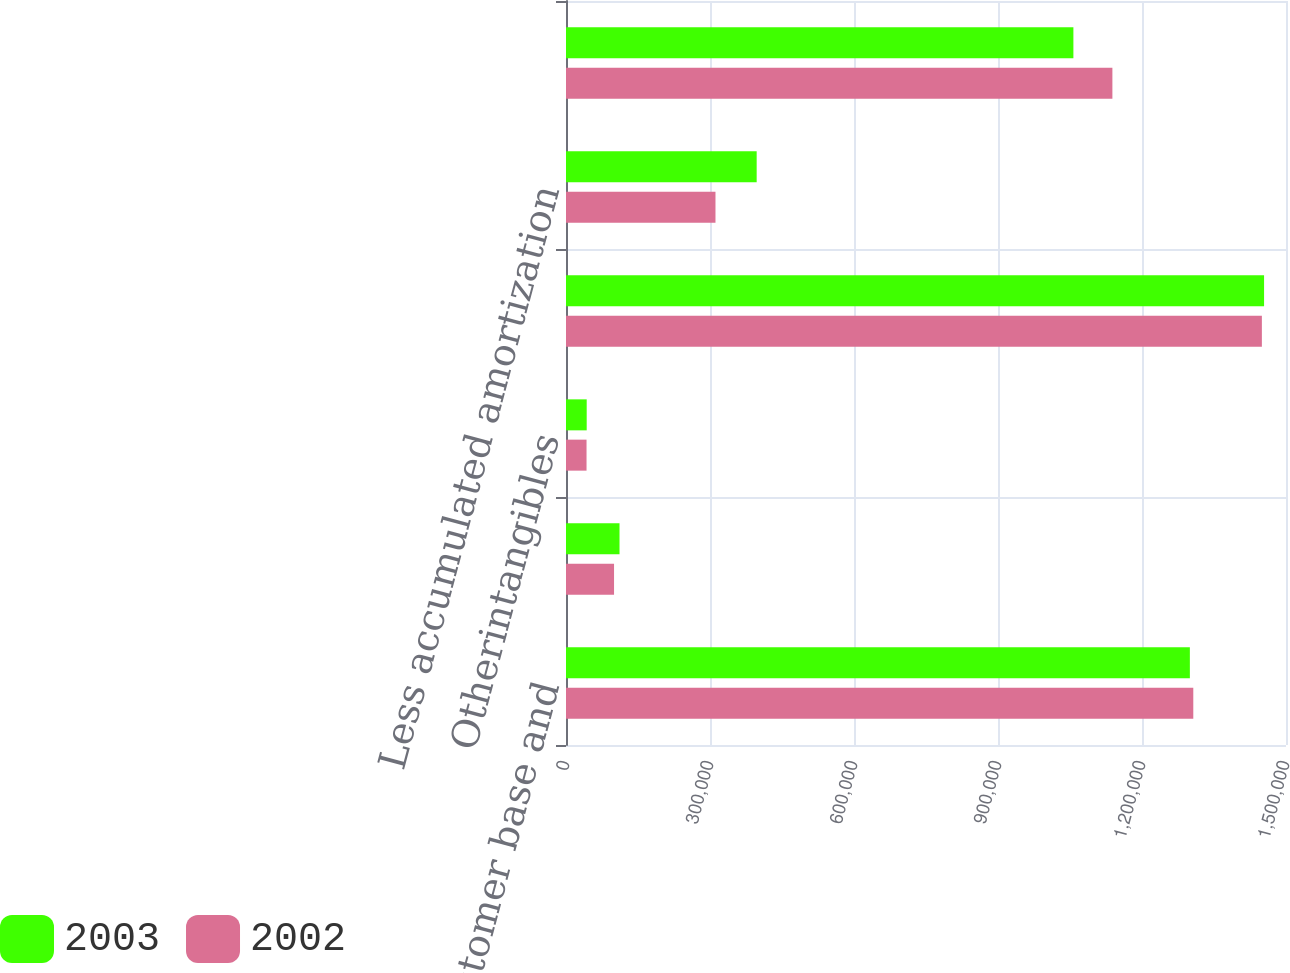Convert chart. <chart><loc_0><loc_0><loc_500><loc_500><stacked_bar_chart><ecel><fcel>Acquired customer base and<fcel>Deferred financing costs<fcel>Otherintangibles<fcel>Total<fcel>Less accumulated amortization<fcel>Other intangible assets net<nl><fcel>2003<fcel>1.29971e+06<fcel>111484<fcel>43125<fcel>1.45432e+06<fcel>397240<fcel>1.05708e+06<nl><fcel>2002<fcel>1.30686e+06<fcel>100091<fcel>42788<fcel>1.44974e+06<fcel>311424<fcel>1.13832e+06<nl></chart> 